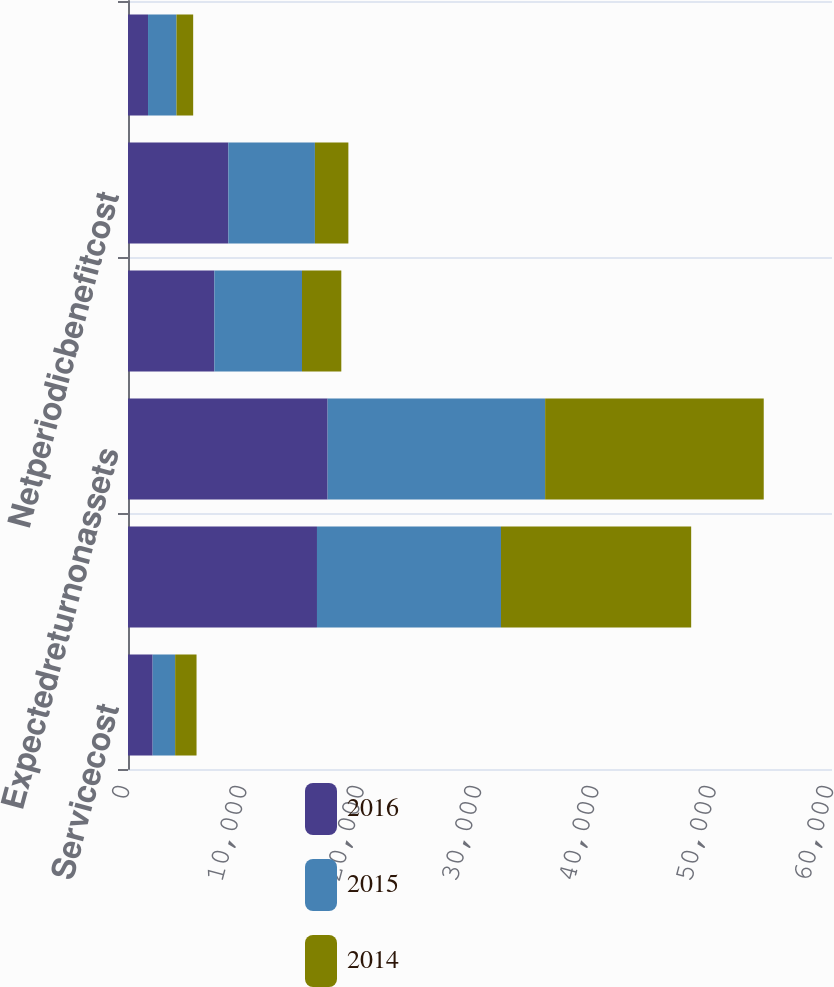Convert chart. <chart><loc_0><loc_0><loc_500><loc_500><stacked_bar_chart><ecel><fcel>Servicecost<fcel>Interestcost<fcel>Expectedreturnonassets<fcel>Amortizationofactuarialloss<fcel>Netperiodicbenefitcost<fcel>Netperiodicbenefitcost(income)<nl><fcel>2016<fcel>2100<fcel>16106<fcel>17013<fcel>7361<fcel>8554<fcel>1707<nl><fcel>2015<fcel>1918<fcel>15683<fcel>18538<fcel>7468<fcel>7377<fcel>2425<nl><fcel>2014<fcel>1824<fcel>16209<fcel>18631<fcel>3351<fcel>2851<fcel>1423<nl></chart> 